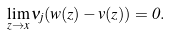<formula> <loc_0><loc_0><loc_500><loc_500>\lim _ { z \to x } \nu _ { j } ( w ( z ) - v ( z ) ) = 0 .</formula> 